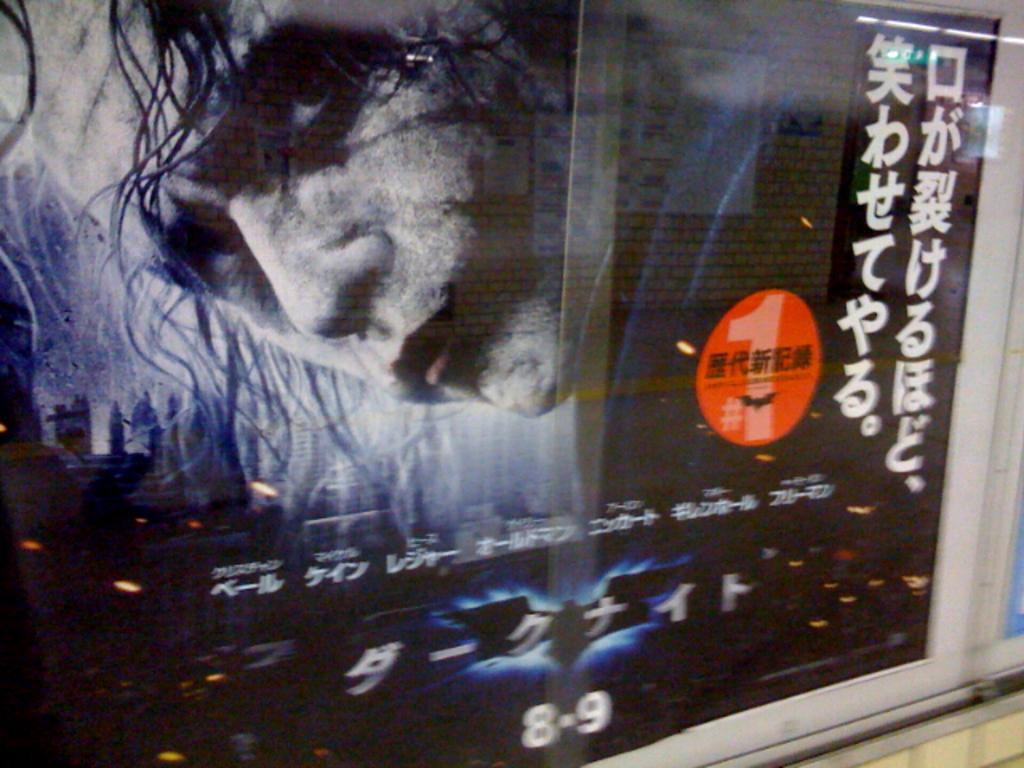<image>
Provide a brief description of the given image. A poster showing the Joker in Batman the movie. 